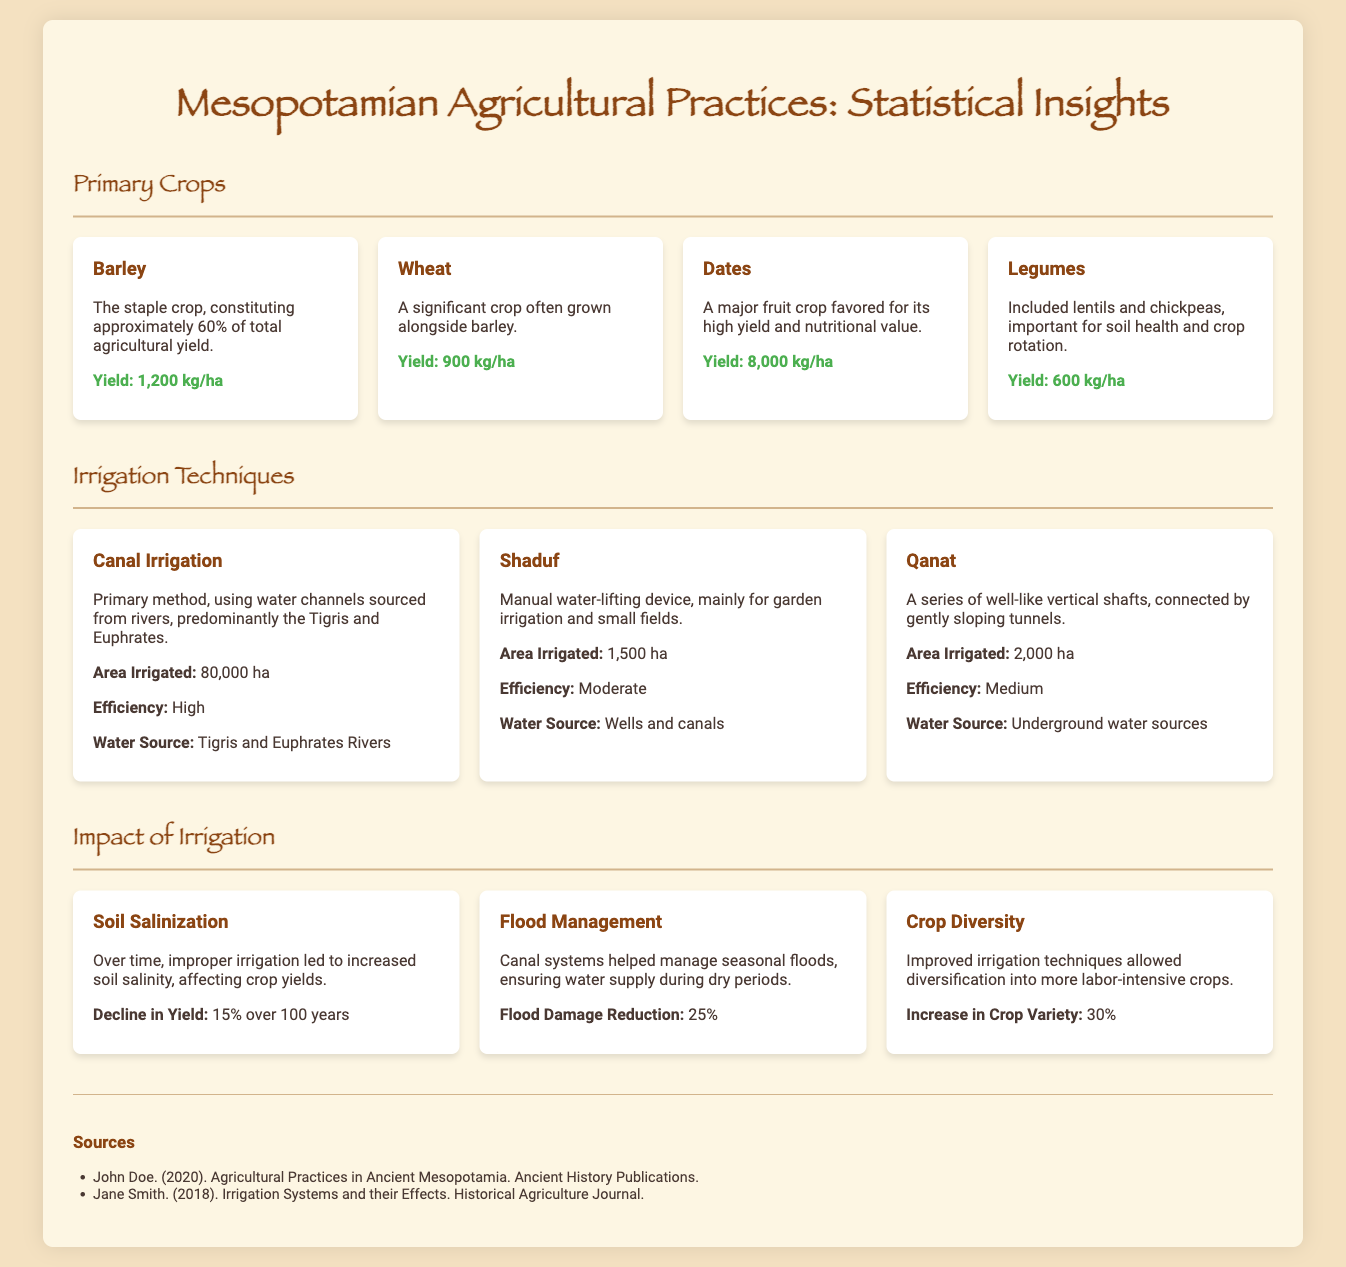What is the staple crop in Mesopotamia? The staple crop is specifically identified in the document, comprising approximately 60% of total agricultural yield.
Answer: Barley What is the yield of wheat? The document states the yield of wheat clearly, allowing for straightforward retrieval.
Answer: 900 kg/ha Which irrigation technique uses a manual water-lifting device? The document mentions the specific irrigation technique that utilizes a manual water-lifting device for garden irrigation.
Answer: Shaduf How much area does canal irrigation cover? The document provides specific area coverage details for this irrigation method.
Answer: 80,000 ha What was the decline in yield due to soil salinization? The decline in yield due to this problem is clearly stated in the document and allows for easy retrieval.
Answer: 15% over 100 years What was the impact of improved irrigation techniques on crop diversity? The document explains the effect of improved irrigation techniques, which can be easily referenced.
Answer: 30% What is the primary water source for canal irrigation? The primary source of water for this irrigation method is noted in the document.
Answer: Tigris and Euphrates Rivers What percentage of flood damage reduction is attributed to canal systems? The document explicitly mentions this statistic, making it easy to locate.
Answer: 25% 